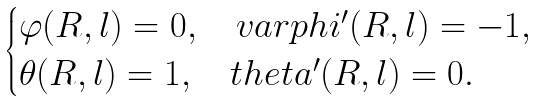Convert formula to latex. <formula><loc_0><loc_0><loc_500><loc_500>\begin{cases} \varphi ( R , l ) = 0 , \quad v a r p h i ^ { \prime } ( R , l ) = - 1 , \\ \theta ( R , l ) = 1 , \quad t h e t a ^ { \prime } ( R , l ) = 0 . \end{cases}</formula> 